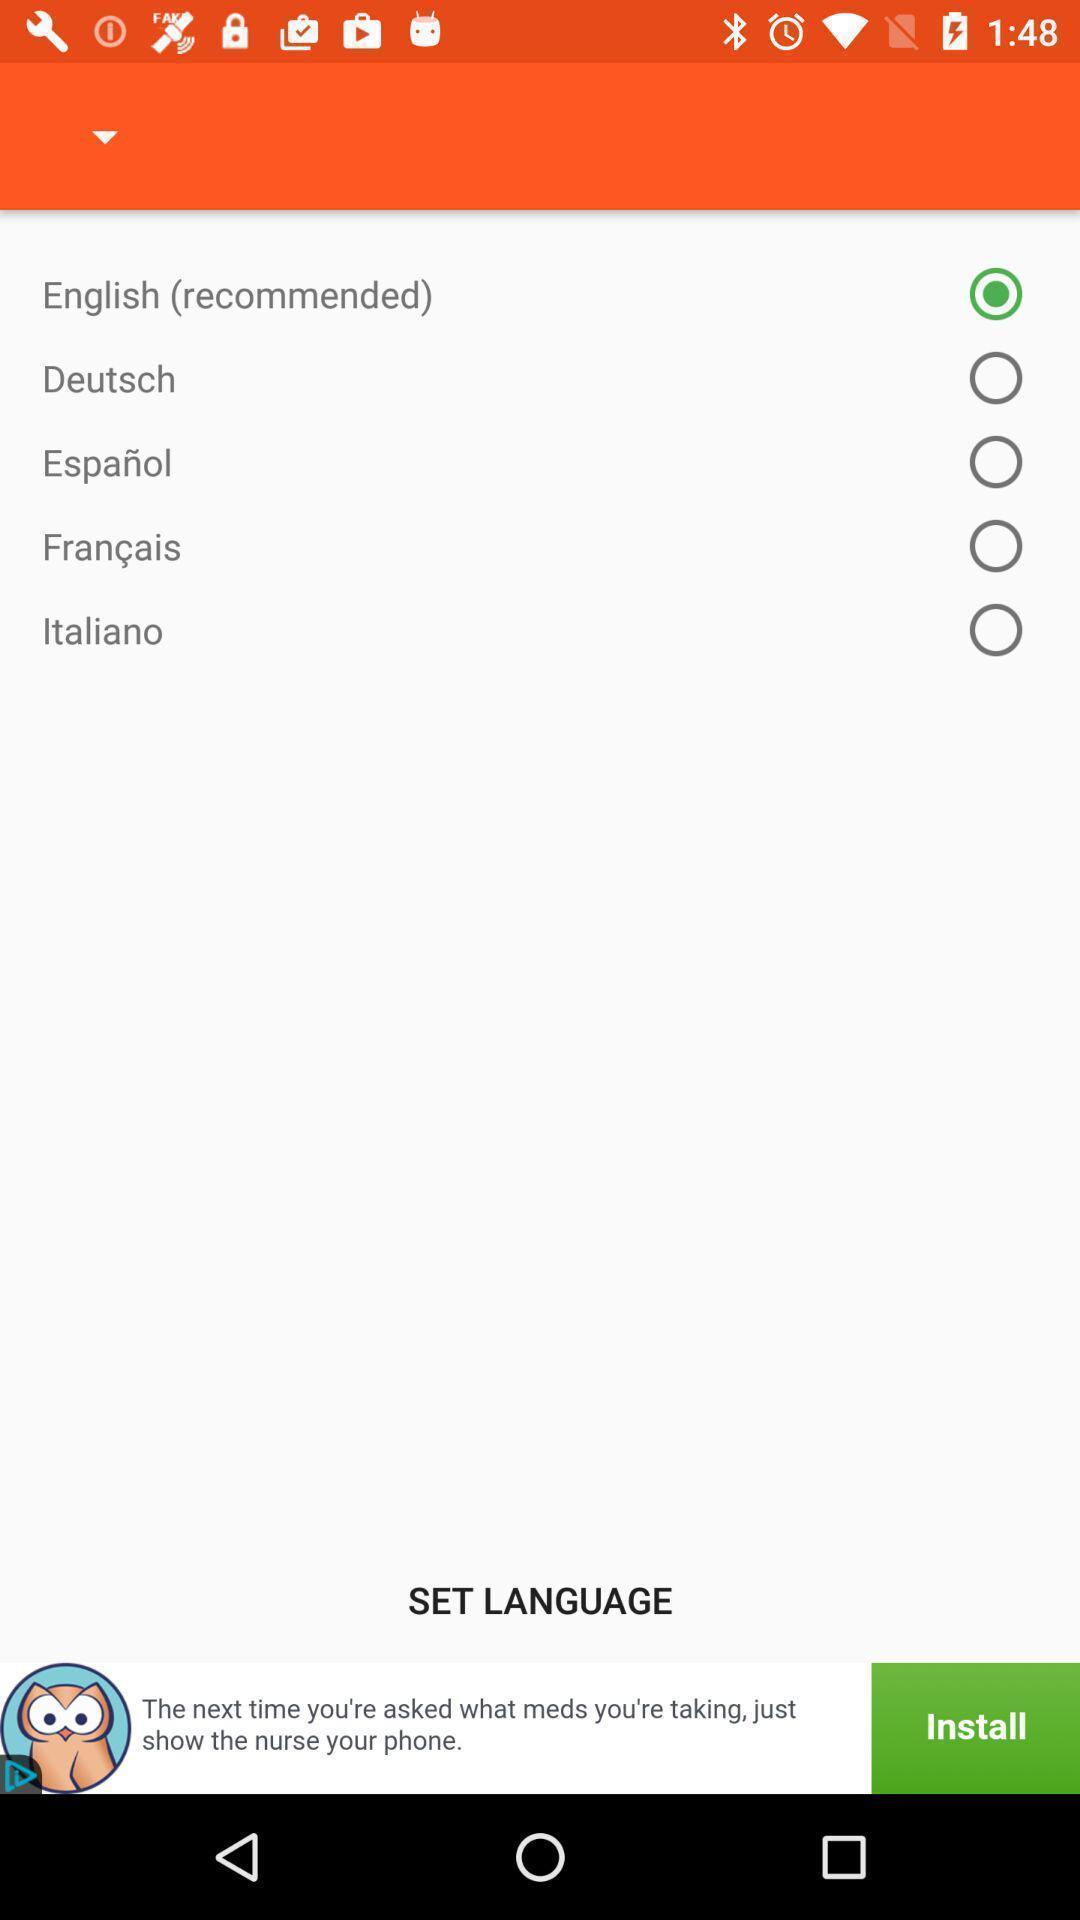Summarize the information in this screenshot. Page showing different languages to select. 